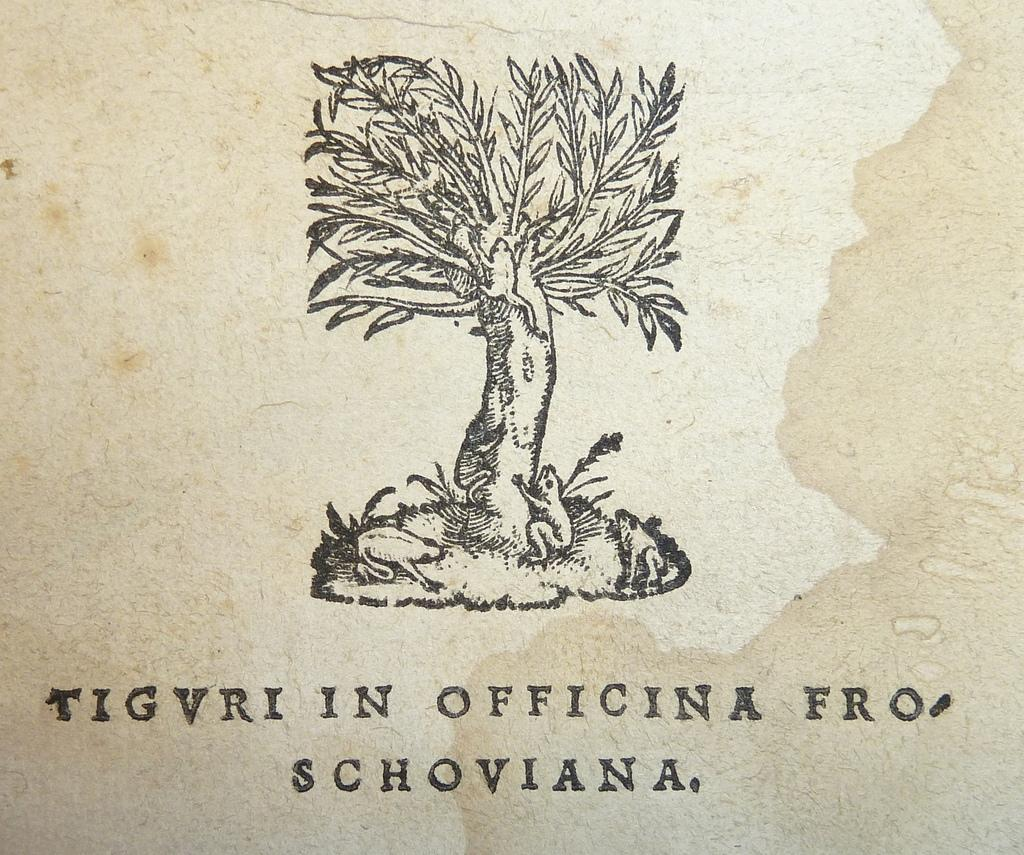What type of vegetation can be seen in the image? There is a tree and plants in the image. What animals are present in the image? There are frogs in the image. Is there any text visible in the image? Yes, there is text in the image. What color is the background of the image? The background of the image is white. Can you describe the flame that is present in the image? There is no flame present in the image. What type of war is depicted in the image? There is no war depicted in the image. 